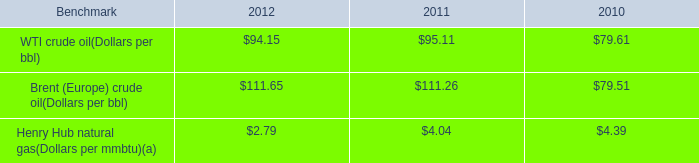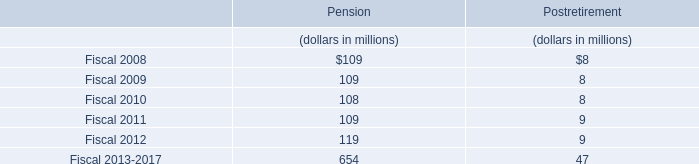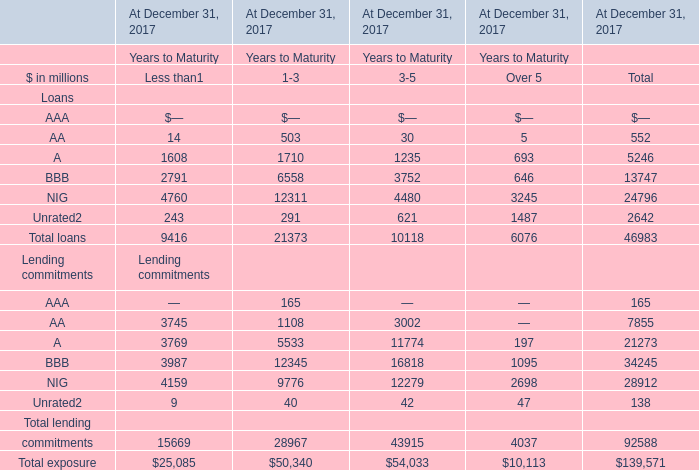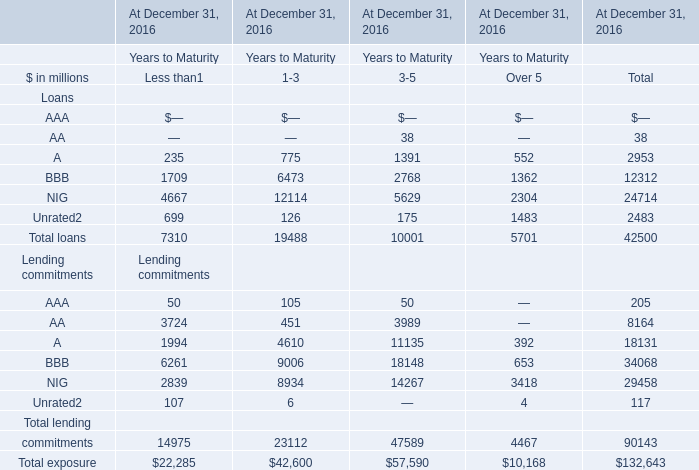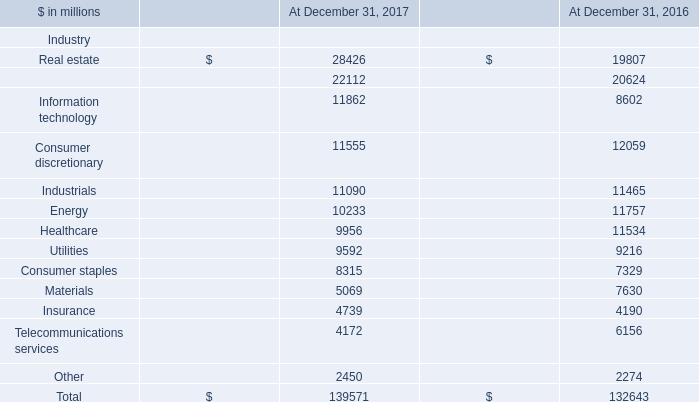What is the average amount of BBB Loans of At December 31, 2016 Years to Maturity.2, and Materials of At December 31, 2017 ? 
Computations: ((2768.0 + 5069.0) / 2)
Answer: 3918.5. 